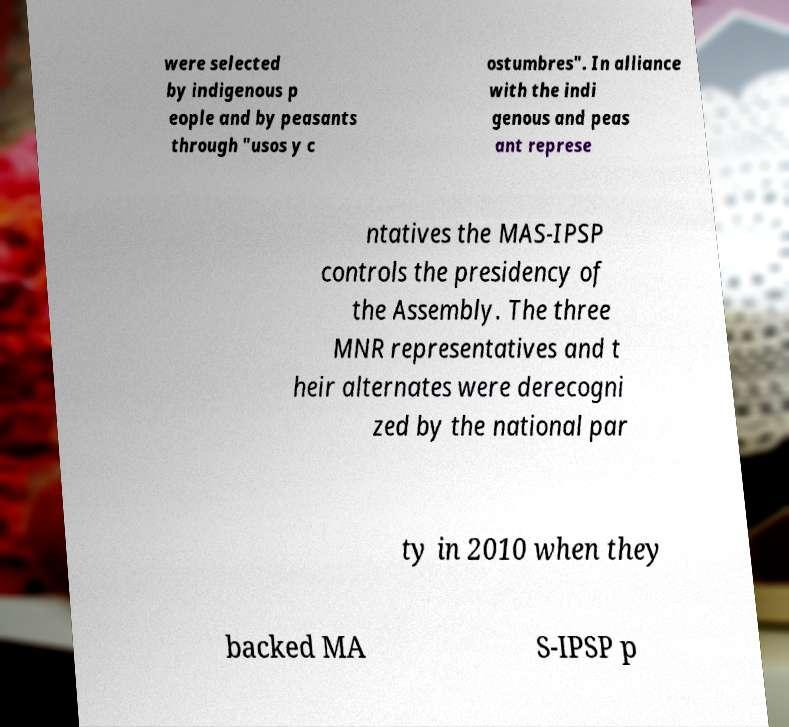I need the written content from this picture converted into text. Can you do that? were selected by indigenous p eople and by peasants through "usos y c ostumbres". In alliance with the indi genous and peas ant represe ntatives the MAS-IPSP controls the presidency of the Assembly. The three MNR representatives and t heir alternates were derecogni zed by the national par ty in 2010 when they backed MA S-IPSP p 